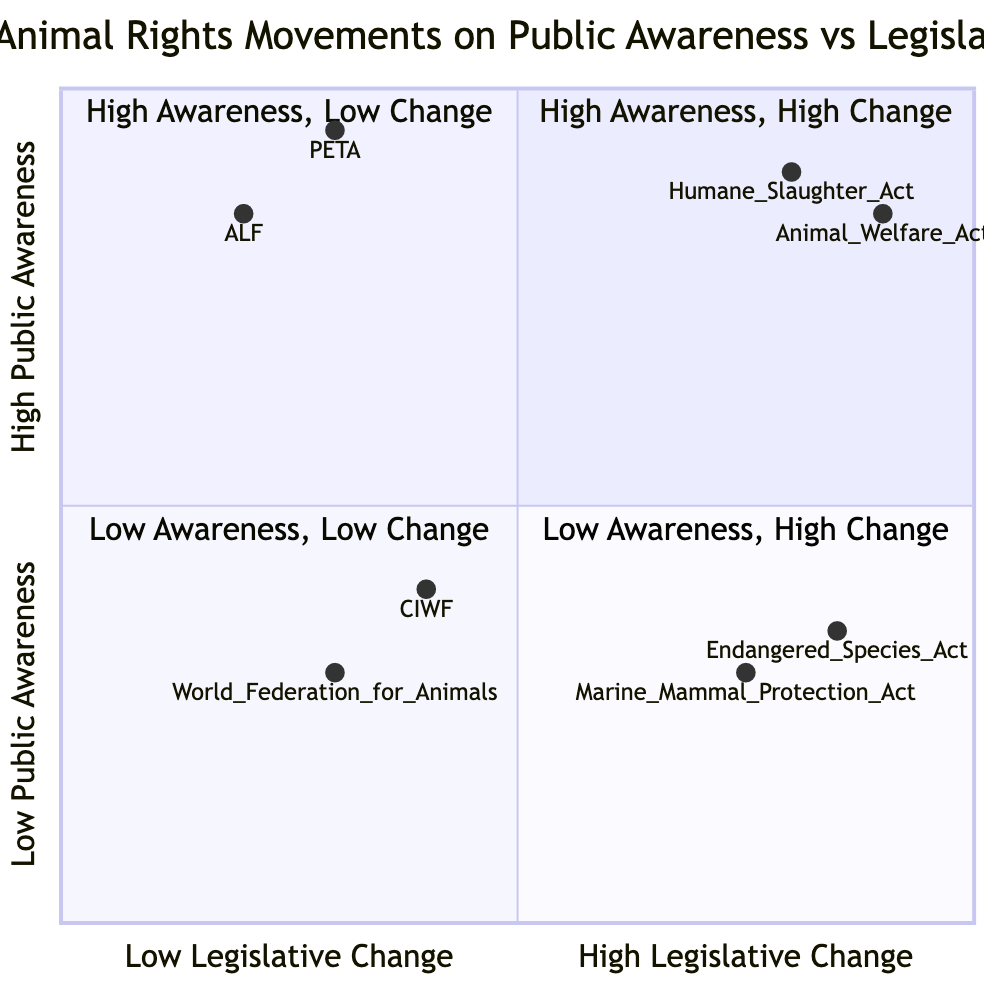What is the element in the "High Public Awareness, High Legislative Change" quadrant that was enacted in 1958? In the quadrant labeled "High Public Awareness, High Legislative Change," one of the elements listed is "The Humane Slaughter Act," which corresponds to the year 1958.
Answer: The Humane Slaughter Act Which animal rights movement has high public awareness but limited legislative success? In the "High Public Awareness, Low Legislative Change" quadrant, the movements included are "People for the Ethical Treatment of Animals (PETA)" and "Animal Liberation Front (ALF)," but PETA is specifically noted for its significant public awareness and challenges in legislation.
Answer: People for the Ethical Treatment of Animals (PETA) What is the public awareness level for the Marine Mammal Protection Act? The Marine Mammal Protection Act is located in the "Low Public Awareness, High Legislative Change" quadrant, and its public awareness level is identified as 0.3 on the y-axis.
Answer: 0.3 How many elements are in the "Low Public Awareness, Low Legislative Change" quadrant? Reviewing the "Low Public Awareness, Low Legislative Change" quadrant, it is found to have two elements: "Compassion in World Farming (CIWF)" and "World Federation for Animals." Therefore, the count of elements is two.
Answer: 2 Which act was enacted with low public awareness but led to significant legislative changes in 1972? The "Marine Mammal Protection Act" is found in the "Low Public Awareness, High Legislative Change" quadrant and was enacted in 1972, while also noting the low public awareness it initially received.
Answer: Marine Mammal Protection Act In which quadrant does the Animal Welfare Act appear? The Animal Welfare Act is located within the quadrant labeled "High Public Awareness, High Legislative Change," indicating both high public awareness and legislative impact.
Answer: High Public Awareness, High Legislative Change Which movement, founded in 1980, has achieved significant public awareness yet struggles with legislative changes? "People for the Ethical Treatment of Animals (PETA)" fits this description as it is placed within the "High Public Awareness, Low Legislative Change" quadrant, highlighting its renowned public campaigns yet low success in legislation.
Answer: People for the Ethical Treatment of Animals (PETA) 